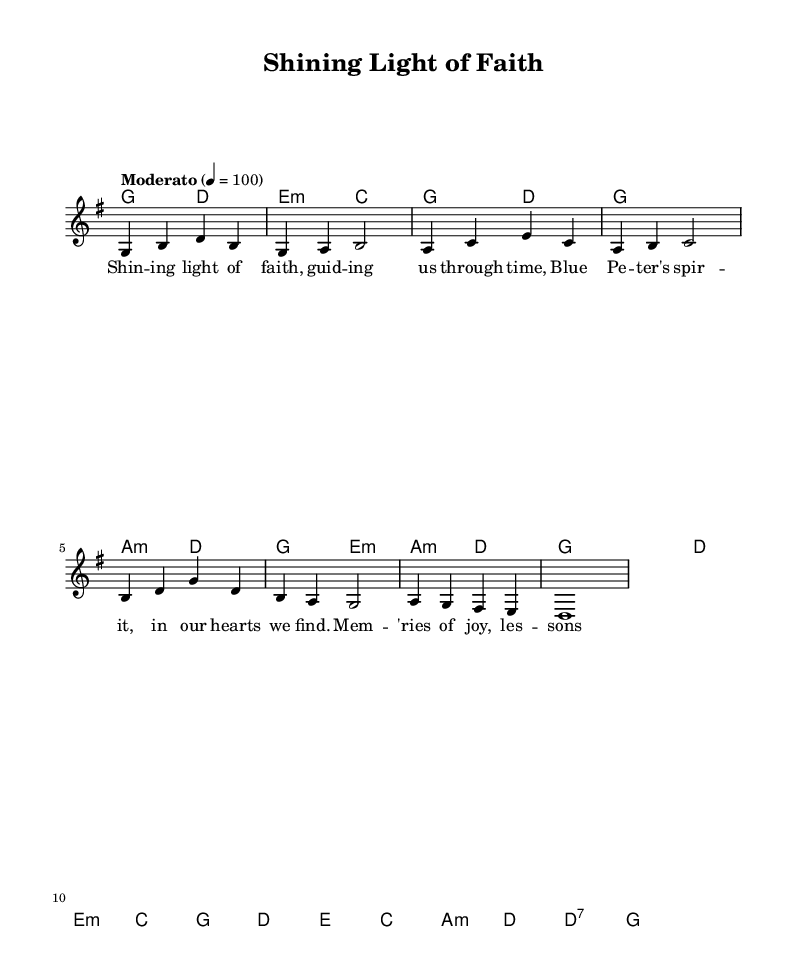What is the key signature of this music? The key signature is indicated by the "g" at the beginning of the global variable section, which denotes that the piece is in G major. G major contains one sharp, F sharp.
Answer: G major What is the time signature? The time signature is indicated by the "4/4" in the global variable section. This means there are four beats per measure and a quarter note receives one beat.
Answer: 4/4 What is the tempo marking? The tempo marking is indicated in the "tempo" line, which states "Moderato" with a tempo of 100 beats per minute. This instructs performers to play at a moderate speed.
Answer: Moderato 100 How many measures are in the melody? To determine the number of measures, we count the segments divided by the vertical bar lines in the melody section. Counting reveals there are 8 measures.
Answer: 8 What is the first note of the melody? The first note is represented as "g" in the melody line, as it starts with a G note.
Answer: g How many different chords are used in the harmonies? By analyzing the chord mode section, we list the unique chords: G, D, E minor, C, and A minor. This gives us a total of 5 different chords used.
Answer: 5 What is the primary theme conveyed through the lyrics? The lyrics focus on concepts of guidance and spiritual reflection, indicating that the theme revolves around light, love, and shared memories of both faith and the beloved show, Blue Peter.
Answer: Guidance 